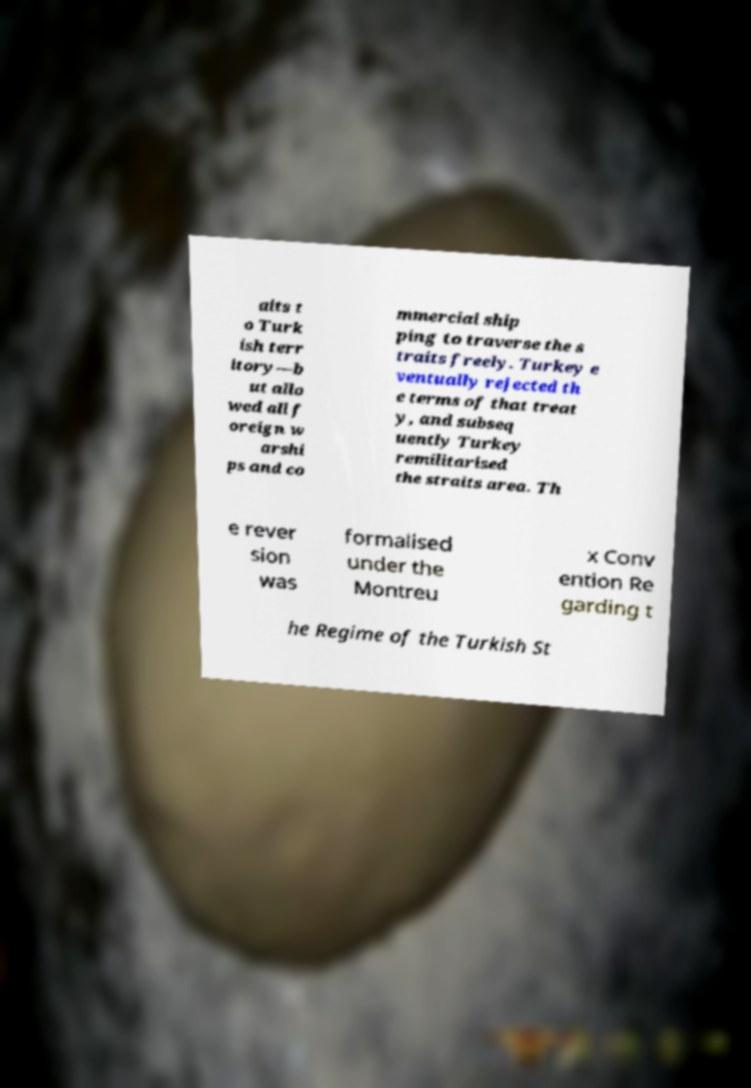What messages or text are displayed in this image? I need them in a readable, typed format. aits t o Turk ish terr itory—b ut allo wed all f oreign w arshi ps and co mmercial ship ping to traverse the s traits freely. Turkey e ventually rejected th e terms of that treat y, and subseq uently Turkey remilitarised the straits area. Th e rever sion was formalised under the Montreu x Conv ention Re garding t he Regime of the Turkish St 